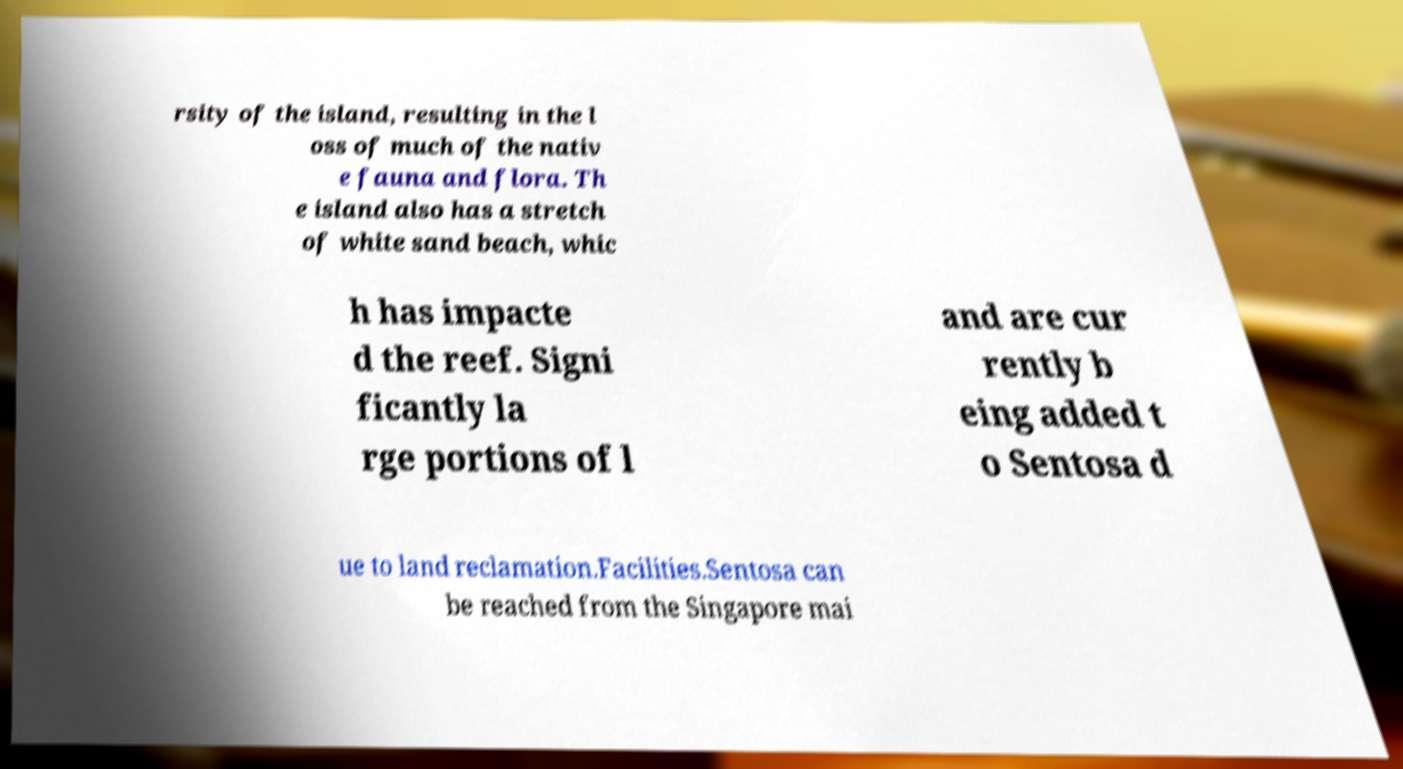For documentation purposes, I need the text within this image transcribed. Could you provide that? rsity of the island, resulting in the l oss of much of the nativ e fauna and flora. Th e island also has a stretch of white sand beach, whic h has impacte d the reef. Signi ficantly la rge portions of l and are cur rently b eing added t o Sentosa d ue to land reclamation.Facilities.Sentosa can be reached from the Singapore mai 